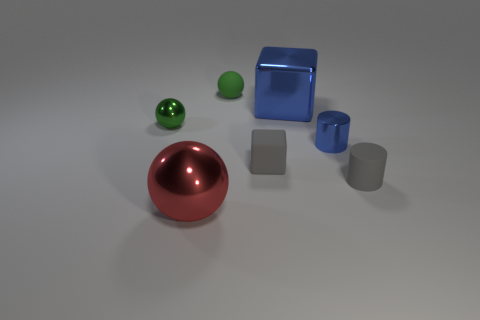Add 3 small yellow matte balls. How many objects exist? 10 Subtract all cylinders. How many objects are left? 5 Add 4 gray matte blocks. How many gray matte blocks are left? 5 Add 1 small cylinders. How many small cylinders exist? 3 Subtract 0 purple spheres. How many objects are left? 7 Subtract all gray objects. Subtract all small blue things. How many objects are left? 4 